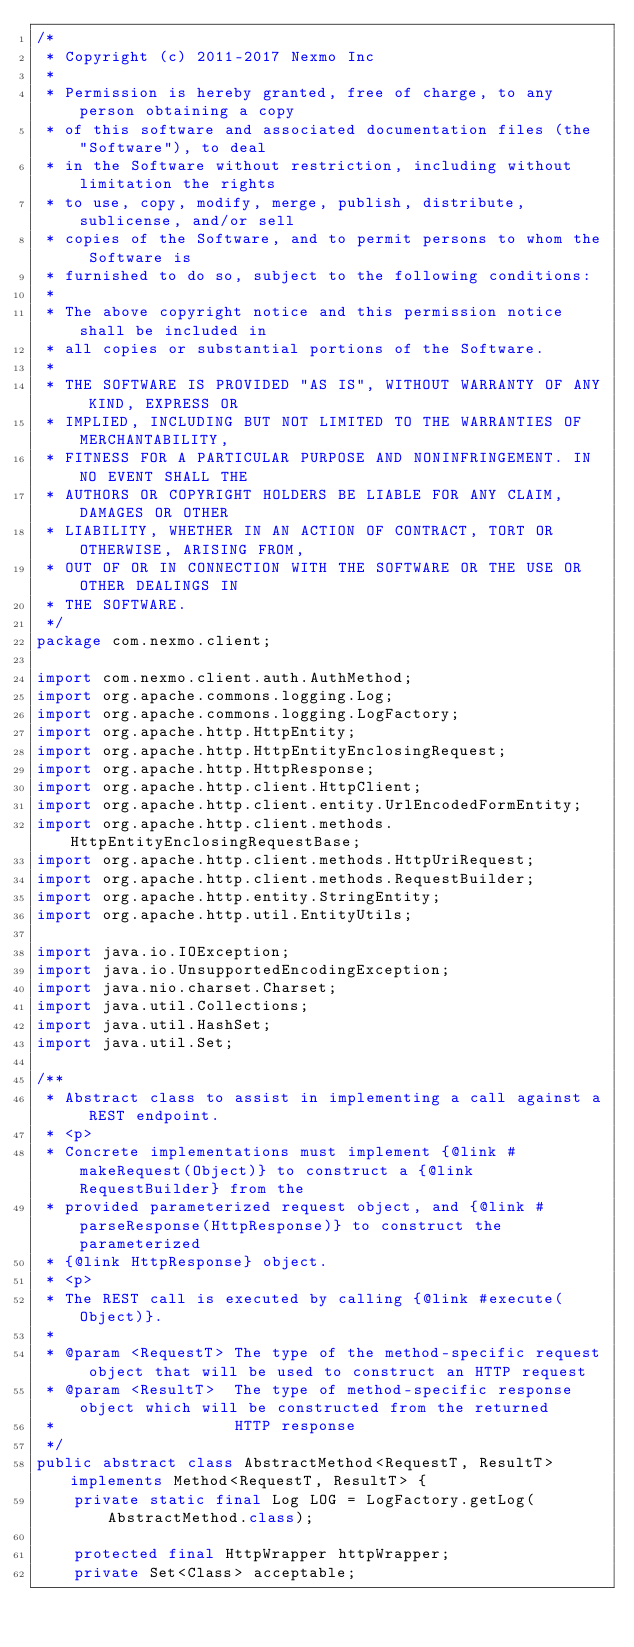<code> <loc_0><loc_0><loc_500><loc_500><_Java_>/*
 * Copyright (c) 2011-2017 Nexmo Inc
 *
 * Permission is hereby granted, free of charge, to any person obtaining a copy
 * of this software and associated documentation files (the "Software"), to deal
 * in the Software without restriction, including without limitation the rights
 * to use, copy, modify, merge, publish, distribute, sublicense, and/or sell
 * copies of the Software, and to permit persons to whom the Software is
 * furnished to do so, subject to the following conditions:
 *
 * The above copyright notice and this permission notice shall be included in
 * all copies or substantial portions of the Software.
 *
 * THE SOFTWARE IS PROVIDED "AS IS", WITHOUT WARRANTY OF ANY KIND, EXPRESS OR
 * IMPLIED, INCLUDING BUT NOT LIMITED TO THE WARRANTIES OF MERCHANTABILITY,
 * FITNESS FOR A PARTICULAR PURPOSE AND NONINFRINGEMENT. IN NO EVENT SHALL THE
 * AUTHORS OR COPYRIGHT HOLDERS BE LIABLE FOR ANY CLAIM, DAMAGES OR OTHER
 * LIABILITY, WHETHER IN AN ACTION OF CONTRACT, TORT OR OTHERWISE, ARISING FROM,
 * OUT OF OR IN CONNECTION WITH THE SOFTWARE OR THE USE OR OTHER DEALINGS IN
 * THE SOFTWARE.
 */
package com.nexmo.client;

import com.nexmo.client.auth.AuthMethod;
import org.apache.commons.logging.Log;
import org.apache.commons.logging.LogFactory;
import org.apache.http.HttpEntity;
import org.apache.http.HttpEntityEnclosingRequest;
import org.apache.http.HttpResponse;
import org.apache.http.client.HttpClient;
import org.apache.http.client.entity.UrlEncodedFormEntity;
import org.apache.http.client.methods.HttpEntityEnclosingRequestBase;
import org.apache.http.client.methods.HttpUriRequest;
import org.apache.http.client.methods.RequestBuilder;
import org.apache.http.entity.StringEntity;
import org.apache.http.util.EntityUtils;

import java.io.IOException;
import java.io.UnsupportedEncodingException;
import java.nio.charset.Charset;
import java.util.Collections;
import java.util.HashSet;
import java.util.Set;

/**
 * Abstract class to assist in implementing a call against a REST endpoint.
 * <p>
 * Concrete implementations must implement {@link #makeRequest(Object)} to construct a {@link RequestBuilder} from the
 * provided parameterized request object, and {@link #parseResponse(HttpResponse)} to construct the parameterized
 * {@link HttpResponse} object.
 * <p>
 * The REST call is executed by calling {@link #execute(Object)}.
 *
 * @param <RequestT> The type of the method-specific request object that will be used to construct an HTTP request
 * @param <ResultT>  The type of method-specific response object which will be constructed from the returned
 *                   HTTP response
 */
public abstract class AbstractMethod<RequestT, ResultT> implements Method<RequestT, ResultT> {
    private static final Log LOG = LogFactory.getLog(AbstractMethod.class);

    protected final HttpWrapper httpWrapper;
    private Set<Class> acceptable;
</code> 